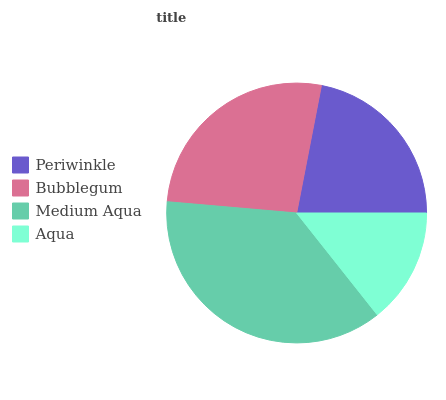Is Aqua the minimum?
Answer yes or no. Yes. Is Medium Aqua the maximum?
Answer yes or no. Yes. Is Bubblegum the minimum?
Answer yes or no. No. Is Bubblegum the maximum?
Answer yes or no. No. Is Bubblegum greater than Periwinkle?
Answer yes or no. Yes. Is Periwinkle less than Bubblegum?
Answer yes or no. Yes. Is Periwinkle greater than Bubblegum?
Answer yes or no. No. Is Bubblegum less than Periwinkle?
Answer yes or no. No. Is Bubblegum the high median?
Answer yes or no. Yes. Is Periwinkle the low median?
Answer yes or no. Yes. Is Medium Aqua the high median?
Answer yes or no. No. Is Bubblegum the low median?
Answer yes or no. No. 